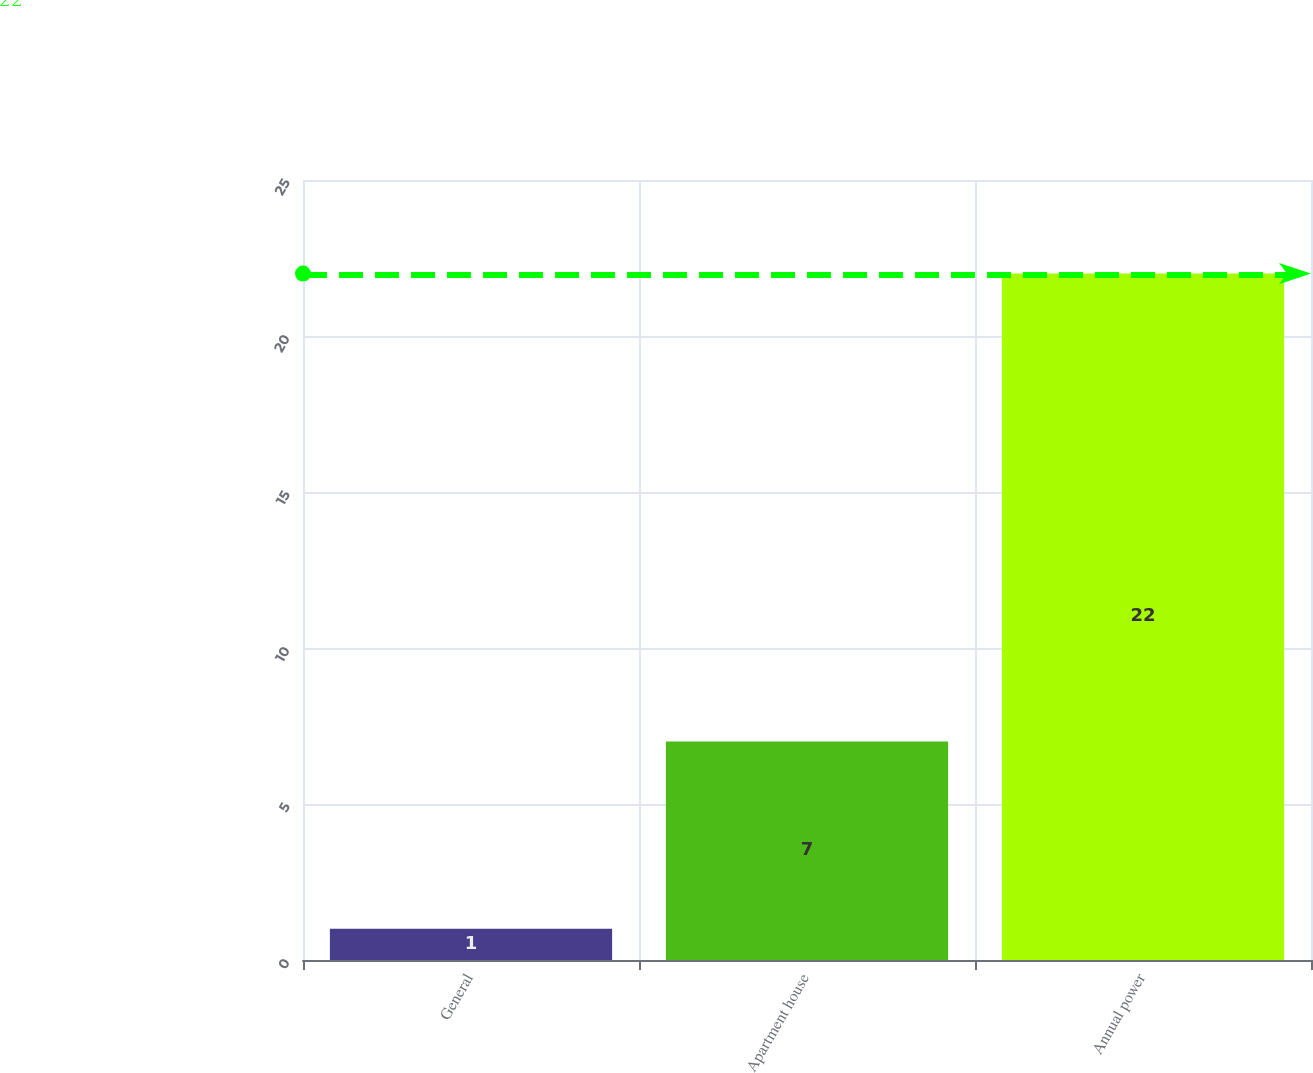<chart> <loc_0><loc_0><loc_500><loc_500><bar_chart><fcel>General<fcel>Apartment house<fcel>Annual power<nl><fcel>1<fcel>7<fcel>22<nl></chart> 